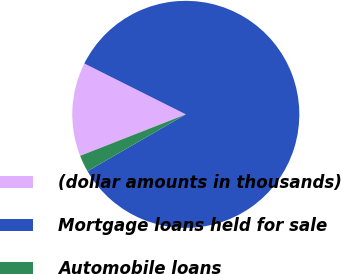<chart> <loc_0><loc_0><loc_500><loc_500><pie_chart><fcel>(dollar amounts in thousands)<fcel>Mortgage loans held for sale<fcel>Automobile loans<nl><fcel>13.35%<fcel>84.27%<fcel>2.39%<nl></chart> 